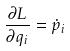<formula> <loc_0><loc_0><loc_500><loc_500>\frac { \partial L } { \partial q _ { i } } = \dot { p } _ { i }</formula> 